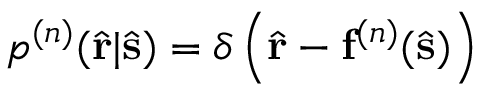Convert formula to latex. <formula><loc_0><loc_0><loc_500><loc_500>p ^ { ( n ) } ( \hat { r } | \hat { s } ) = \delta \left ( \hat { r } - f ^ { ( n ) } ( \hat { s } ) \right )</formula> 